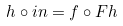<formula> <loc_0><loc_0><loc_500><loc_500>h \circ i n = f \circ F h</formula> 